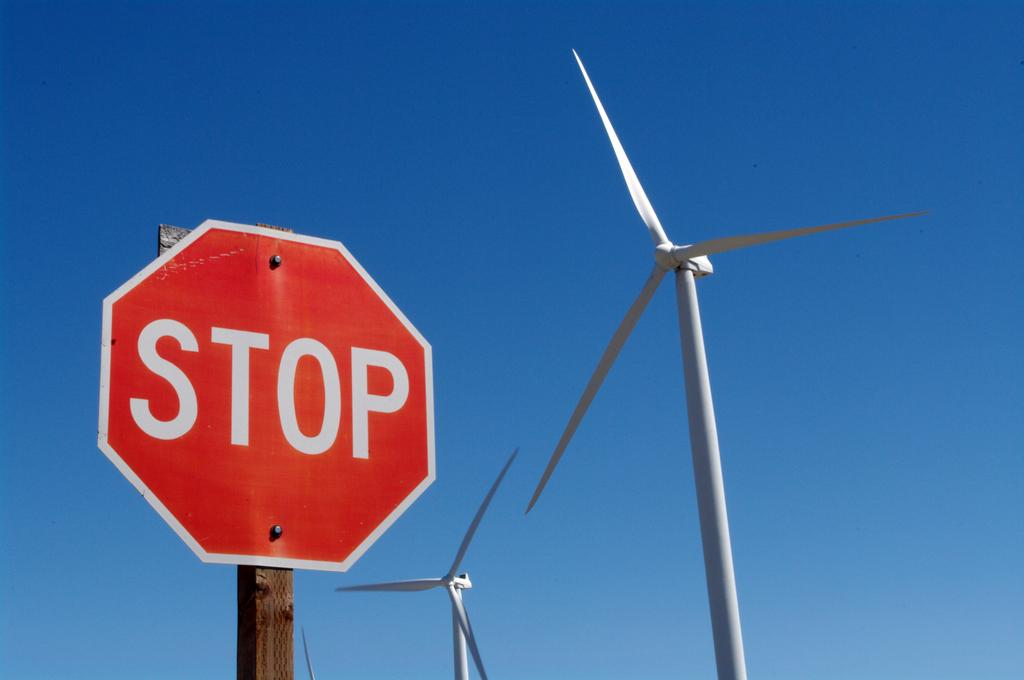<image>
Render a clear and concise summary of the photo. a stop sign that is outside in the daytime 